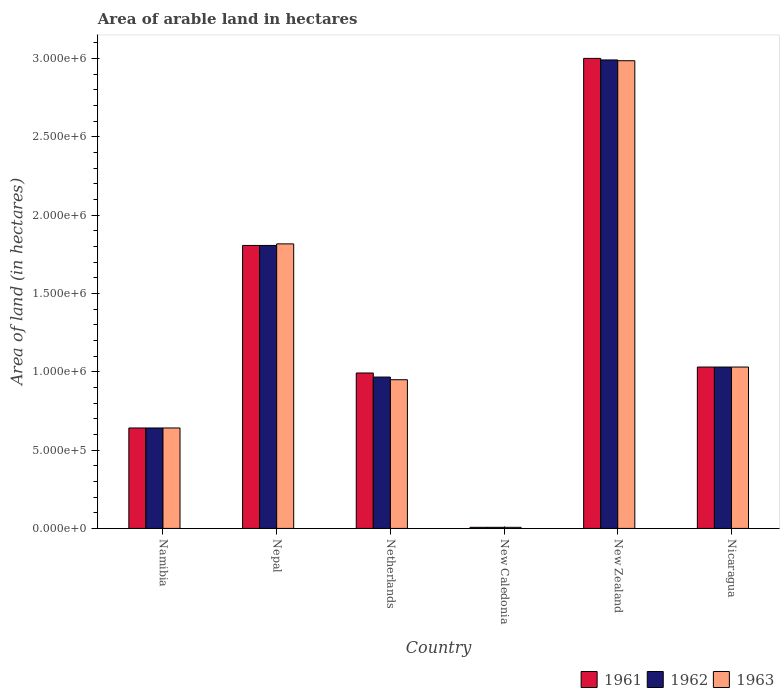How many different coloured bars are there?
Your response must be concise. 3. Are the number of bars on each tick of the X-axis equal?
Offer a very short reply. Yes. How many bars are there on the 1st tick from the left?
Provide a short and direct response. 3. What is the label of the 3rd group of bars from the left?
Your answer should be compact. Netherlands. In how many cases, is the number of bars for a given country not equal to the number of legend labels?
Keep it short and to the point. 0. What is the total arable land in 1961 in New Caledonia?
Give a very brief answer. 7000. Across all countries, what is the maximum total arable land in 1962?
Make the answer very short. 2.99e+06. Across all countries, what is the minimum total arable land in 1961?
Offer a very short reply. 7000. In which country was the total arable land in 1962 maximum?
Keep it short and to the point. New Zealand. In which country was the total arable land in 1961 minimum?
Keep it short and to the point. New Caledonia. What is the total total arable land in 1961 in the graph?
Your answer should be compact. 7.48e+06. What is the difference between the total arable land in 1962 in Nepal and that in New Zealand?
Your response must be concise. -1.18e+06. What is the difference between the total arable land in 1962 in Nepal and the total arable land in 1963 in Netherlands?
Your answer should be very brief. 8.57e+05. What is the average total arable land in 1961 per country?
Give a very brief answer. 1.25e+06. In how many countries, is the total arable land in 1962 greater than 200000 hectares?
Provide a short and direct response. 5. What is the ratio of the total arable land in 1961 in Nepal to that in New Caledonia?
Your answer should be very brief. 258. What is the difference between the highest and the second highest total arable land in 1963?
Give a very brief answer. 1.96e+06. What is the difference between the highest and the lowest total arable land in 1961?
Make the answer very short. 2.99e+06. What does the 2nd bar from the left in Nepal represents?
Provide a succinct answer. 1962. Is it the case that in every country, the sum of the total arable land in 1961 and total arable land in 1962 is greater than the total arable land in 1963?
Give a very brief answer. Yes. Are all the bars in the graph horizontal?
Offer a very short reply. No. What is the difference between two consecutive major ticks on the Y-axis?
Keep it short and to the point. 5.00e+05. Does the graph contain any zero values?
Ensure brevity in your answer.  No. Does the graph contain grids?
Offer a terse response. No. Where does the legend appear in the graph?
Make the answer very short. Bottom right. How many legend labels are there?
Make the answer very short. 3. What is the title of the graph?
Your answer should be very brief. Area of arable land in hectares. Does "1971" appear as one of the legend labels in the graph?
Provide a short and direct response. No. What is the label or title of the X-axis?
Offer a terse response. Country. What is the label or title of the Y-axis?
Offer a very short reply. Area of land (in hectares). What is the Area of land (in hectares) of 1961 in Namibia?
Ensure brevity in your answer.  6.41e+05. What is the Area of land (in hectares) in 1962 in Namibia?
Your response must be concise. 6.41e+05. What is the Area of land (in hectares) in 1963 in Namibia?
Give a very brief answer. 6.41e+05. What is the Area of land (in hectares) of 1961 in Nepal?
Give a very brief answer. 1.81e+06. What is the Area of land (in hectares) of 1962 in Nepal?
Offer a very short reply. 1.81e+06. What is the Area of land (in hectares) in 1963 in Nepal?
Keep it short and to the point. 1.82e+06. What is the Area of land (in hectares) in 1961 in Netherlands?
Your response must be concise. 9.92e+05. What is the Area of land (in hectares) of 1962 in Netherlands?
Offer a very short reply. 9.66e+05. What is the Area of land (in hectares) of 1963 in Netherlands?
Offer a terse response. 9.49e+05. What is the Area of land (in hectares) in 1961 in New Caledonia?
Give a very brief answer. 7000. What is the Area of land (in hectares) of 1962 in New Caledonia?
Give a very brief answer. 7000. What is the Area of land (in hectares) in 1963 in New Caledonia?
Keep it short and to the point. 7000. What is the Area of land (in hectares) of 1961 in New Zealand?
Offer a very short reply. 3.00e+06. What is the Area of land (in hectares) of 1962 in New Zealand?
Provide a short and direct response. 2.99e+06. What is the Area of land (in hectares) of 1963 in New Zealand?
Ensure brevity in your answer.  2.98e+06. What is the Area of land (in hectares) in 1961 in Nicaragua?
Your answer should be very brief. 1.03e+06. What is the Area of land (in hectares) of 1962 in Nicaragua?
Your answer should be compact. 1.03e+06. What is the Area of land (in hectares) of 1963 in Nicaragua?
Your answer should be very brief. 1.03e+06. Across all countries, what is the maximum Area of land (in hectares) of 1961?
Your answer should be very brief. 3.00e+06. Across all countries, what is the maximum Area of land (in hectares) in 1962?
Your answer should be very brief. 2.99e+06. Across all countries, what is the maximum Area of land (in hectares) of 1963?
Your answer should be compact. 2.98e+06. Across all countries, what is the minimum Area of land (in hectares) in 1961?
Offer a very short reply. 7000. Across all countries, what is the minimum Area of land (in hectares) in 1962?
Offer a very short reply. 7000. Across all countries, what is the minimum Area of land (in hectares) in 1963?
Give a very brief answer. 7000. What is the total Area of land (in hectares) in 1961 in the graph?
Provide a succinct answer. 7.48e+06. What is the total Area of land (in hectares) in 1962 in the graph?
Your response must be concise. 7.44e+06. What is the total Area of land (in hectares) of 1963 in the graph?
Your answer should be compact. 7.43e+06. What is the difference between the Area of land (in hectares) in 1961 in Namibia and that in Nepal?
Your answer should be very brief. -1.16e+06. What is the difference between the Area of land (in hectares) in 1962 in Namibia and that in Nepal?
Provide a short and direct response. -1.16e+06. What is the difference between the Area of land (in hectares) in 1963 in Namibia and that in Nepal?
Your response must be concise. -1.18e+06. What is the difference between the Area of land (in hectares) in 1961 in Namibia and that in Netherlands?
Your response must be concise. -3.51e+05. What is the difference between the Area of land (in hectares) in 1962 in Namibia and that in Netherlands?
Ensure brevity in your answer.  -3.25e+05. What is the difference between the Area of land (in hectares) of 1963 in Namibia and that in Netherlands?
Your response must be concise. -3.08e+05. What is the difference between the Area of land (in hectares) of 1961 in Namibia and that in New Caledonia?
Your answer should be very brief. 6.34e+05. What is the difference between the Area of land (in hectares) in 1962 in Namibia and that in New Caledonia?
Your answer should be very brief. 6.34e+05. What is the difference between the Area of land (in hectares) in 1963 in Namibia and that in New Caledonia?
Ensure brevity in your answer.  6.34e+05. What is the difference between the Area of land (in hectares) of 1961 in Namibia and that in New Zealand?
Offer a terse response. -2.36e+06. What is the difference between the Area of land (in hectares) in 1962 in Namibia and that in New Zealand?
Your answer should be very brief. -2.35e+06. What is the difference between the Area of land (in hectares) of 1963 in Namibia and that in New Zealand?
Give a very brief answer. -2.34e+06. What is the difference between the Area of land (in hectares) in 1961 in Namibia and that in Nicaragua?
Offer a very short reply. -3.89e+05. What is the difference between the Area of land (in hectares) of 1962 in Namibia and that in Nicaragua?
Ensure brevity in your answer.  -3.89e+05. What is the difference between the Area of land (in hectares) of 1963 in Namibia and that in Nicaragua?
Provide a short and direct response. -3.89e+05. What is the difference between the Area of land (in hectares) of 1961 in Nepal and that in Netherlands?
Ensure brevity in your answer.  8.14e+05. What is the difference between the Area of land (in hectares) of 1962 in Nepal and that in Netherlands?
Your answer should be compact. 8.40e+05. What is the difference between the Area of land (in hectares) of 1963 in Nepal and that in Netherlands?
Keep it short and to the point. 8.67e+05. What is the difference between the Area of land (in hectares) in 1961 in Nepal and that in New Caledonia?
Ensure brevity in your answer.  1.80e+06. What is the difference between the Area of land (in hectares) of 1962 in Nepal and that in New Caledonia?
Offer a terse response. 1.80e+06. What is the difference between the Area of land (in hectares) in 1963 in Nepal and that in New Caledonia?
Make the answer very short. 1.81e+06. What is the difference between the Area of land (in hectares) of 1961 in Nepal and that in New Zealand?
Keep it short and to the point. -1.19e+06. What is the difference between the Area of land (in hectares) of 1962 in Nepal and that in New Zealand?
Your answer should be compact. -1.18e+06. What is the difference between the Area of land (in hectares) of 1963 in Nepal and that in New Zealand?
Your answer should be compact. -1.17e+06. What is the difference between the Area of land (in hectares) of 1961 in Nepal and that in Nicaragua?
Provide a succinct answer. 7.76e+05. What is the difference between the Area of land (in hectares) in 1962 in Nepal and that in Nicaragua?
Offer a very short reply. 7.76e+05. What is the difference between the Area of land (in hectares) of 1963 in Nepal and that in Nicaragua?
Make the answer very short. 7.86e+05. What is the difference between the Area of land (in hectares) in 1961 in Netherlands and that in New Caledonia?
Give a very brief answer. 9.85e+05. What is the difference between the Area of land (in hectares) of 1962 in Netherlands and that in New Caledonia?
Provide a short and direct response. 9.59e+05. What is the difference between the Area of land (in hectares) in 1963 in Netherlands and that in New Caledonia?
Your response must be concise. 9.42e+05. What is the difference between the Area of land (in hectares) of 1961 in Netherlands and that in New Zealand?
Ensure brevity in your answer.  -2.01e+06. What is the difference between the Area of land (in hectares) in 1962 in Netherlands and that in New Zealand?
Your answer should be compact. -2.02e+06. What is the difference between the Area of land (in hectares) of 1963 in Netherlands and that in New Zealand?
Make the answer very short. -2.04e+06. What is the difference between the Area of land (in hectares) of 1961 in Netherlands and that in Nicaragua?
Offer a very short reply. -3.80e+04. What is the difference between the Area of land (in hectares) of 1962 in Netherlands and that in Nicaragua?
Give a very brief answer. -6.40e+04. What is the difference between the Area of land (in hectares) of 1963 in Netherlands and that in Nicaragua?
Your answer should be compact. -8.10e+04. What is the difference between the Area of land (in hectares) of 1961 in New Caledonia and that in New Zealand?
Offer a terse response. -2.99e+06. What is the difference between the Area of land (in hectares) of 1962 in New Caledonia and that in New Zealand?
Your answer should be compact. -2.98e+06. What is the difference between the Area of land (in hectares) of 1963 in New Caledonia and that in New Zealand?
Ensure brevity in your answer.  -2.98e+06. What is the difference between the Area of land (in hectares) in 1961 in New Caledonia and that in Nicaragua?
Offer a very short reply. -1.02e+06. What is the difference between the Area of land (in hectares) of 1962 in New Caledonia and that in Nicaragua?
Make the answer very short. -1.02e+06. What is the difference between the Area of land (in hectares) in 1963 in New Caledonia and that in Nicaragua?
Ensure brevity in your answer.  -1.02e+06. What is the difference between the Area of land (in hectares) in 1961 in New Zealand and that in Nicaragua?
Provide a succinct answer. 1.97e+06. What is the difference between the Area of land (in hectares) in 1962 in New Zealand and that in Nicaragua?
Make the answer very short. 1.96e+06. What is the difference between the Area of land (in hectares) of 1963 in New Zealand and that in Nicaragua?
Make the answer very short. 1.96e+06. What is the difference between the Area of land (in hectares) of 1961 in Namibia and the Area of land (in hectares) of 1962 in Nepal?
Your response must be concise. -1.16e+06. What is the difference between the Area of land (in hectares) of 1961 in Namibia and the Area of land (in hectares) of 1963 in Nepal?
Your answer should be very brief. -1.18e+06. What is the difference between the Area of land (in hectares) in 1962 in Namibia and the Area of land (in hectares) in 1963 in Nepal?
Your response must be concise. -1.18e+06. What is the difference between the Area of land (in hectares) in 1961 in Namibia and the Area of land (in hectares) in 1962 in Netherlands?
Your answer should be very brief. -3.25e+05. What is the difference between the Area of land (in hectares) in 1961 in Namibia and the Area of land (in hectares) in 1963 in Netherlands?
Your answer should be compact. -3.08e+05. What is the difference between the Area of land (in hectares) of 1962 in Namibia and the Area of land (in hectares) of 1963 in Netherlands?
Your answer should be very brief. -3.08e+05. What is the difference between the Area of land (in hectares) of 1961 in Namibia and the Area of land (in hectares) of 1962 in New Caledonia?
Provide a succinct answer. 6.34e+05. What is the difference between the Area of land (in hectares) in 1961 in Namibia and the Area of land (in hectares) in 1963 in New Caledonia?
Provide a short and direct response. 6.34e+05. What is the difference between the Area of land (in hectares) of 1962 in Namibia and the Area of land (in hectares) of 1963 in New Caledonia?
Offer a very short reply. 6.34e+05. What is the difference between the Area of land (in hectares) in 1961 in Namibia and the Area of land (in hectares) in 1962 in New Zealand?
Make the answer very short. -2.35e+06. What is the difference between the Area of land (in hectares) in 1961 in Namibia and the Area of land (in hectares) in 1963 in New Zealand?
Keep it short and to the point. -2.34e+06. What is the difference between the Area of land (in hectares) in 1962 in Namibia and the Area of land (in hectares) in 1963 in New Zealand?
Ensure brevity in your answer.  -2.34e+06. What is the difference between the Area of land (in hectares) of 1961 in Namibia and the Area of land (in hectares) of 1962 in Nicaragua?
Provide a short and direct response. -3.89e+05. What is the difference between the Area of land (in hectares) of 1961 in Namibia and the Area of land (in hectares) of 1963 in Nicaragua?
Make the answer very short. -3.89e+05. What is the difference between the Area of land (in hectares) in 1962 in Namibia and the Area of land (in hectares) in 1963 in Nicaragua?
Offer a terse response. -3.89e+05. What is the difference between the Area of land (in hectares) in 1961 in Nepal and the Area of land (in hectares) in 1962 in Netherlands?
Offer a very short reply. 8.40e+05. What is the difference between the Area of land (in hectares) in 1961 in Nepal and the Area of land (in hectares) in 1963 in Netherlands?
Offer a terse response. 8.57e+05. What is the difference between the Area of land (in hectares) in 1962 in Nepal and the Area of land (in hectares) in 1963 in Netherlands?
Offer a very short reply. 8.57e+05. What is the difference between the Area of land (in hectares) in 1961 in Nepal and the Area of land (in hectares) in 1962 in New Caledonia?
Your answer should be compact. 1.80e+06. What is the difference between the Area of land (in hectares) in 1961 in Nepal and the Area of land (in hectares) in 1963 in New Caledonia?
Keep it short and to the point. 1.80e+06. What is the difference between the Area of land (in hectares) in 1962 in Nepal and the Area of land (in hectares) in 1963 in New Caledonia?
Keep it short and to the point. 1.80e+06. What is the difference between the Area of land (in hectares) in 1961 in Nepal and the Area of land (in hectares) in 1962 in New Zealand?
Your answer should be very brief. -1.18e+06. What is the difference between the Area of land (in hectares) of 1961 in Nepal and the Area of land (in hectares) of 1963 in New Zealand?
Offer a very short reply. -1.18e+06. What is the difference between the Area of land (in hectares) of 1962 in Nepal and the Area of land (in hectares) of 1963 in New Zealand?
Make the answer very short. -1.18e+06. What is the difference between the Area of land (in hectares) of 1961 in Nepal and the Area of land (in hectares) of 1962 in Nicaragua?
Offer a very short reply. 7.76e+05. What is the difference between the Area of land (in hectares) in 1961 in Nepal and the Area of land (in hectares) in 1963 in Nicaragua?
Provide a short and direct response. 7.76e+05. What is the difference between the Area of land (in hectares) in 1962 in Nepal and the Area of land (in hectares) in 1963 in Nicaragua?
Your answer should be very brief. 7.76e+05. What is the difference between the Area of land (in hectares) in 1961 in Netherlands and the Area of land (in hectares) in 1962 in New Caledonia?
Provide a short and direct response. 9.85e+05. What is the difference between the Area of land (in hectares) of 1961 in Netherlands and the Area of land (in hectares) of 1963 in New Caledonia?
Offer a terse response. 9.85e+05. What is the difference between the Area of land (in hectares) in 1962 in Netherlands and the Area of land (in hectares) in 1963 in New Caledonia?
Keep it short and to the point. 9.59e+05. What is the difference between the Area of land (in hectares) of 1961 in Netherlands and the Area of land (in hectares) of 1962 in New Zealand?
Keep it short and to the point. -2.00e+06. What is the difference between the Area of land (in hectares) of 1961 in Netherlands and the Area of land (in hectares) of 1963 in New Zealand?
Offer a very short reply. -1.99e+06. What is the difference between the Area of land (in hectares) in 1962 in Netherlands and the Area of land (in hectares) in 1963 in New Zealand?
Offer a terse response. -2.02e+06. What is the difference between the Area of land (in hectares) in 1961 in Netherlands and the Area of land (in hectares) in 1962 in Nicaragua?
Offer a very short reply. -3.80e+04. What is the difference between the Area of land (in hectares) of 1961 in Netherlands and the Area of land (in hectares) of 1963 in Nicaragua?
Provide a succinct answer. -3.80e+04. What is the difference between the Area of land (in hectares) in 1962 in Netherlands and the Area of land (in hectares) in 1963 in Nicaragua?
Offer a very short reply. -6.40e+04. What is the difference between the Area of land (in hectares) in 1961 in New Caledonia and the Area of land (in hectares) in 1962 in New Zealand?
Provide a short and direct response. -2.98e+06. What is the difference between the Area of land (in hectares) of 1961 in New Caledonia and the Area of land (in hectares) of 1963 in New Zealand?
Keep it short and to the point. -2.98e+06. What is the difference between the Area of land (in hectares) of 1962 in New Caledonia and the Area of land (in hectares) of 1963 in New Zealand?
Ensure brevity in your answer.  -2.98e+06. What is the difference between the Area of land (in hectares) in 1961 in New Caledonia and the Area of land (in hectares) in 1962 in Nicaragua?
Offer a very short reply. -1.02e+06. What is the difference between the Area of land (in hectares) in 1961 in New Caledonia and the Area of land (in hectares) in 1963 in Nicaragua?
Your response must be concise. -1.02e+06. What is the difference between the Area of land (in hectares) in 1962 in New Caledonia and the Area of land (in hectares) in 1963 in Nicaragua?
Provide a short and direct response. -1.02e+06. What is the difference between the Area of land (in hectares) in 1961 in New Zealand and the Area of land (in hectares) in 1962 in Nicaragua?
Give a very brief answer. 1.97e+06. What is the difference between the Area of land (in hectares) in 1961 in New Zealand and the Area of land (in hectares) in 1963 in Nicaragua?
Offer a very short reply. 1.97e+06. What is the difference between the Area of land (in hectares) of 1962 in New Zealand and the Area of land (in hectares) of 1963 in Nicaragua?
Keep it short and to the point. 1.96e+06. What is the average Area of land (in hectares) in 1961 per country?
Your answer should be compact. 1.25e+06. What is the average Area of land (in hectares) of 1962 per country?
Your answer should be very brief. 1.24e+06. What is the average Area of land (in hectares) in 1963 per country?
Offer a very short reply. 1.24e+06. What is the difference between the Area of land (in hectares) of 1961 and Area of land (in hectares) of 1962 in Namibia?
Your response must be concise. 0. What is the difference between the Area of land (in hectares) in 1961 and Area of land (in hectares) in 1963 in Nepal?
Your answer should be compact. -10000. What is the difference between the Area of land (in hectares) of 1962 and Area of land (in hectares) of 1963 in Nepal?
Ensure brevity in your answer.  -10000. What is the difference between the Area of land (in hectares) in 1961 and Area of land (in hectares) in 1962 in Netherlands?
Your answer should be very brief. 2.60e+04. What is the difference between the Area of land (in hectares) of 1961 and Area of land (in hectares) of 1963 in Netherlands?
Offer a very short reply. 4.30e+04. What is the difference between the Area of land (in hectares) of 1962 and Area of land (in hectares) of 1963 in Netherlands?
Your answer should be compact. 1.70e+04. What is the difference between the Area of land (in hectares) of 1961 and Area of land (in hectares) of 1962 in New Caledonia?
Give a very brief answer. 0. What is the difference between the Area of land (in hectares) in 1961 and Area of land (in hectares) in 1963 in New Zealand?
Offer a terse response. 1.50e+04. What is the difference between the Area of land (in hectares) of 1962 and Area of land (in hectares) of 1963 in New Zealand?
Make the answer very short. 5000. What is the difference between the Area of land (in hectares) of 1962 and Area of land (in hectares) of 1963 in Nicaragua?
Your answer should be very brief. 0. What is the ratio of the Area of land (in hectares) in 1961 in Namibia to that in Nepal?
Your answer should be very brief. 0.35. What is the ratio of the Area of land (in hectares) of 1962 in Namibia to that in Nepal?
Keep it short and to the point. 0.35. What is the ratio of the Area of land (in hectares) of 1963 in Namibia to that in Nepal?
Offer a terse response. 0.35. What is the ratio of the Area of land (in hectares) of 1961 in Namibia to that in Netherlands?
Offer a very short reply. 0.65. What is the ratio of the Area of land (in hectares) in 1962 in Namibia to that in Netherlands?
Your answer should be compact. 0.66. What is the ratio of the Area of land (in hectares) in 1963 in Namibia to that in Netherlands?
Ensure brevity in your answer.  0.68. What is the ratio of the Area of land (in hectares) of 1961 in Namibia to that in New Caledonia?
Provide a short and direct response. 91.57. What is the ratio of the Area of land (in hectares) of 1962 in Namibia to that in New Caledonia?
Your answer should be very brief. 91.57. What is the ratio of the Area of land (in hectares) in 1963 in Namibia to that in New Caledonia?
Your response must be concise. 91.57. What is the ratio of the Area of land (in hectares) of 1961 in Namibia to that in New Zealand?
Keep it short and to the point. 0.21. What is the ratio of the Area of land (in hectares) of 1962 in Namibia to that in New Zealand?
Keep it short and to the point. 0.21. What is the ratio of the Area of land (in hectares) in 1963 in Namibia to that in New Zealand?
Your answer should be very brief. 0.21. What is the ratio of the Area of land (in hectares) of 1961 in Namibia to that in Nicaragua?
Provide a short and direct response. 0.62. What is the ratio of the Area of land (in hectares) of 1962 in Namibia to that in Nicaragua?
Offer a very short reply. 0.62. What is the ratio of the Area of land (in hectares) in 1963 in Namibia to that in Nicaragua?
Make the answer very short. 0.62. What is the ratio of the Area of land (in hectares) in 1961 in Nepal to that in Netherlands?
Your response must be concise. 1.82. What is the ratio of the Area of land (in hectares) in 1962 in Nepal to that in Netherlands?
Your answer should be very brief. 1.87. What is the ratio of the Area of land (in hectares) in 1963 in Nepal to that in Netherlands?
Offer a very short reply. 1.91. What is the ratio of the Area of land (in hectares) of 1961 in Nepal to that in New Caledonia?
Ensure brevity in your answer.  258. What is the ratio of the Area of land (in hectares) of 1962 in Nepal to that in New Caledonia?
Offer a very short reply. 258. What is the ratio of the Area of land (in hectares) in 1963 in Nepal to that in New Caledonia?
Give a very brief answer. 259.43. What is the ratio of the Area of land (in hectares) of 1961 in Nepal to that in New Zealand?
Give a very brief answer. 0.6. What is the ratio of the Area of land (in hectares) in 1962 in Nepal to that in New Zealand?
Your answer should be compact. 0.6. What is the ratio of the Area of land (in hectares) in 1963 in Nepal to that in New Zealand?
Give a very brief answer. 0.61. What is the ratio of the Area of land (in hectares) in 1961 in Nepal to that in Nicaragua?
Your response must be concise. 1.75. What is the ratio of the Area of land (in hectares) in 1962 in Nepal to that in Nicaragua?
Make the answer very short. 1.75. What is the ratio of the Area of land (in hectares) in 1963 in Nepal to that in Nicaragua?
Your answer should be compact. 1.76. What is the ratio of the Area of land (in hectares) in 1961 in Netherlands to that in New Caledonia?
Ensure brevity in your answer.  141.71. What is the ratio of the Area of land (in hectares) in 1962 in Netherlands to that in New Caledonia?
Ensure brevity in your answer.  138. What is the ratio of the Area of land (in hectares) of 1963 in Netherlands to that in New Caledonia?
Keep it short and to the point. 135.57. What is the ratio of the Area of land (in hectares) of 1961 in Netherlands to that in New Zealand?
Your response must be concise. 0.33. What is the ratio of the Area of land (in hectares) in 1962 in Netherlands to that in New Zealand?
Offer a very short reply. 0.32. What is the ratio of the Area of land (in hectares) in 1963 in Netherlands to that in New Zealand?
Make the answer very short. 0.32. What is the ratio of the Area of land (in hectares) in 1961 in Netherlands to that in Nicaragua?
Your answer should be very brief. 0.96. What is the ratio of the Area of land (in hectares) of 1962 in Netherlands to that in Nicaragua?
Your response must be concise. 0.94. What is the ratio of the Area of land (in hectares) in 1963 in Netherlands to that in Nicaragua?
Give a very brief answer. 0.92. What is the ratio of the Area of land (in hectares) of 1961 in New Caledonia to that in New Zealand?
Ensure brevity in your answer.  0. What is the ratio of the Area of land (in hectares) in 1962 in New Caledonia to that in New Zealand?
Ensure brevity in your answer.  0. What is the ratio of the Area of land (in hectares) of 1963 in New Caledonia to that in New Zealand?
Offer a very short reply. 0. What is the ratio of the Area of land (in hectares) of 1961 in New Caledonia to that in Nicaragua?
Provide a succinct answer. 0.01. What is the ratio of the Area of land (in hectares) in 1962 in New Caledonia to that in Nicaragua?
Your response must be concise. 0.01. What is the ratio of the Area of land (in hectares) in 1963 in New Caledonia to that in Nicaragua?
Provide a short and direct response. 0.01. What is the ratio of the Area of land (in hectares) in 1961 in New Zealand to that in Nicaragua?
Give a very brief answer. 2.91. What is the ratio of the Area of land (in hectares) in 1962 in New Zealand to that in Nicaragua?
Your response must be concise. 2.9. What is the ratio of the Area of land (in hectares) of 1963 in New Zealand to that in Nicaragua?
Your response must be concise. 2.9. What is the difference between the highest and the second highest Area of land (in hectares) in 1961?
Your answer should be compact. 1.19e+06. What is the difference between the highest and the second highest Area of land (in hectares) of 1962?
Provide a short and direct response. 1.18e+06. What is the difference between the highest and the second highest Area of land (in hectares) in 1963?
Keep it short and to the point. 1.17e+06. What is the difference between the highest and the lowest Area of land (in hectares) in 1961?
Your answer should be very brief. 2.99e+06. What is the difference between the highest and the lowest Area of land (in hectares) in 1962?
Give a very brief answer. 2.98e+06. What is the difference between the highest and the lowest Area of land (in hectares) of 1963?
Offer a very short reply. 2.98e+06. 